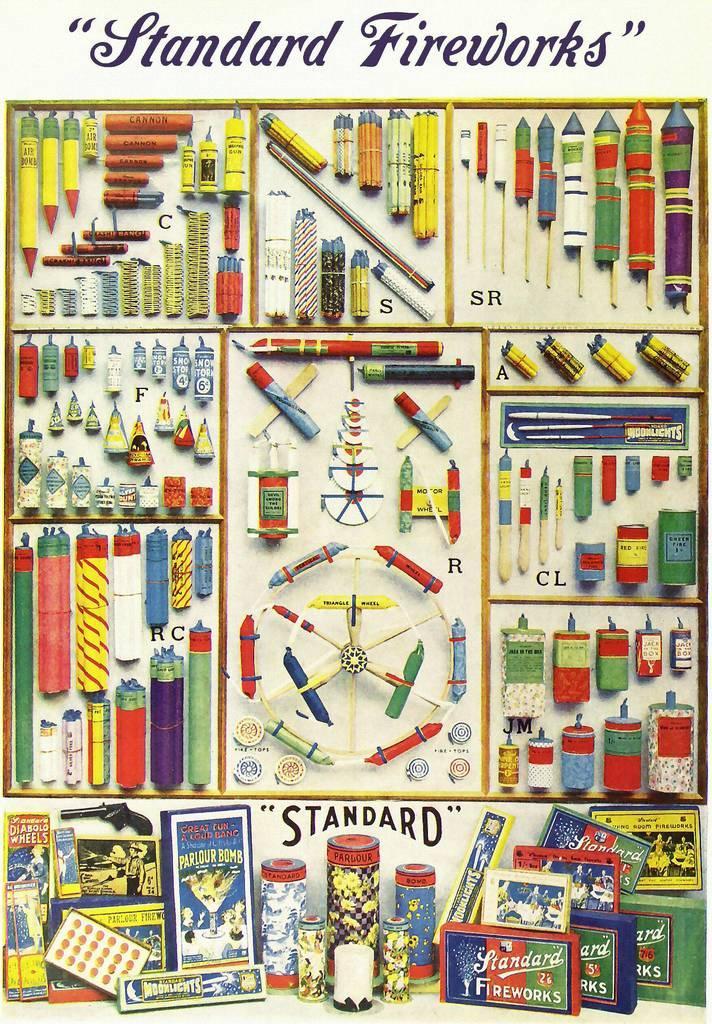<image>
Present a compact description of the photo's key features. A huge poster from Standard Fireworks showing all different types. 